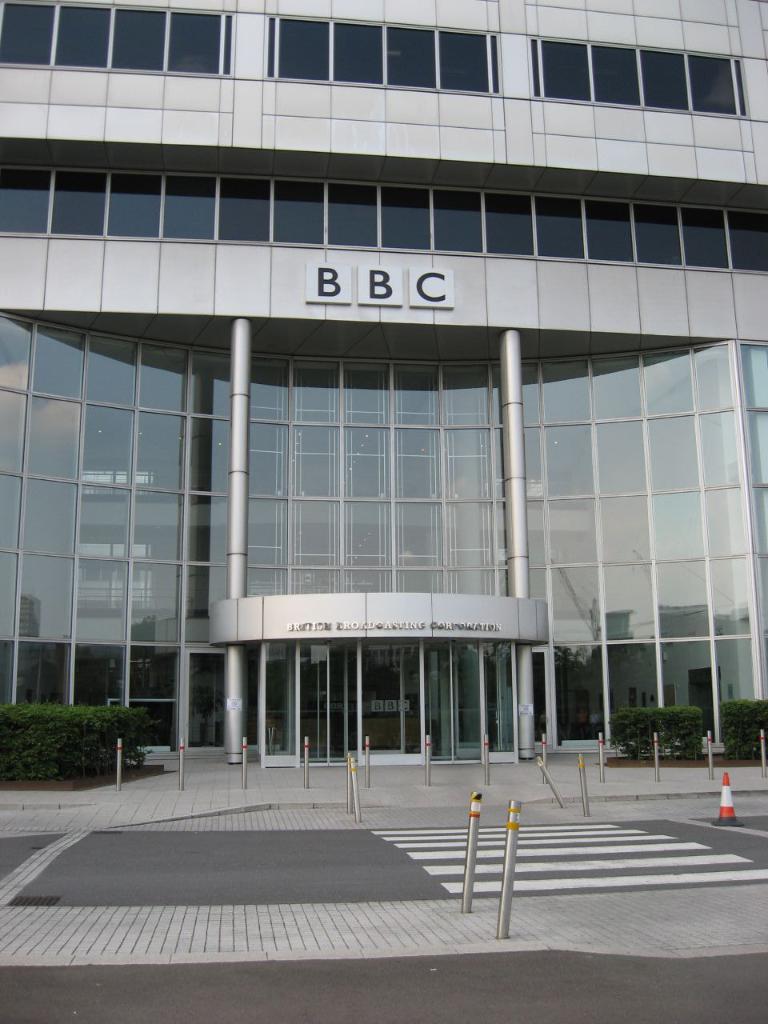Could you give a brief overview of what you see in this image? It is a BBC organization, it has plenty of windows and the front part of the organization is made up of glass and in front of that there are some plants and there are some iron rods kept in an order to walk into the office. On the right side there is a traffic cone. 